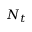<formula> <loc_0><loc_0><loc_500><loc_500>N _ { t }</formula> 